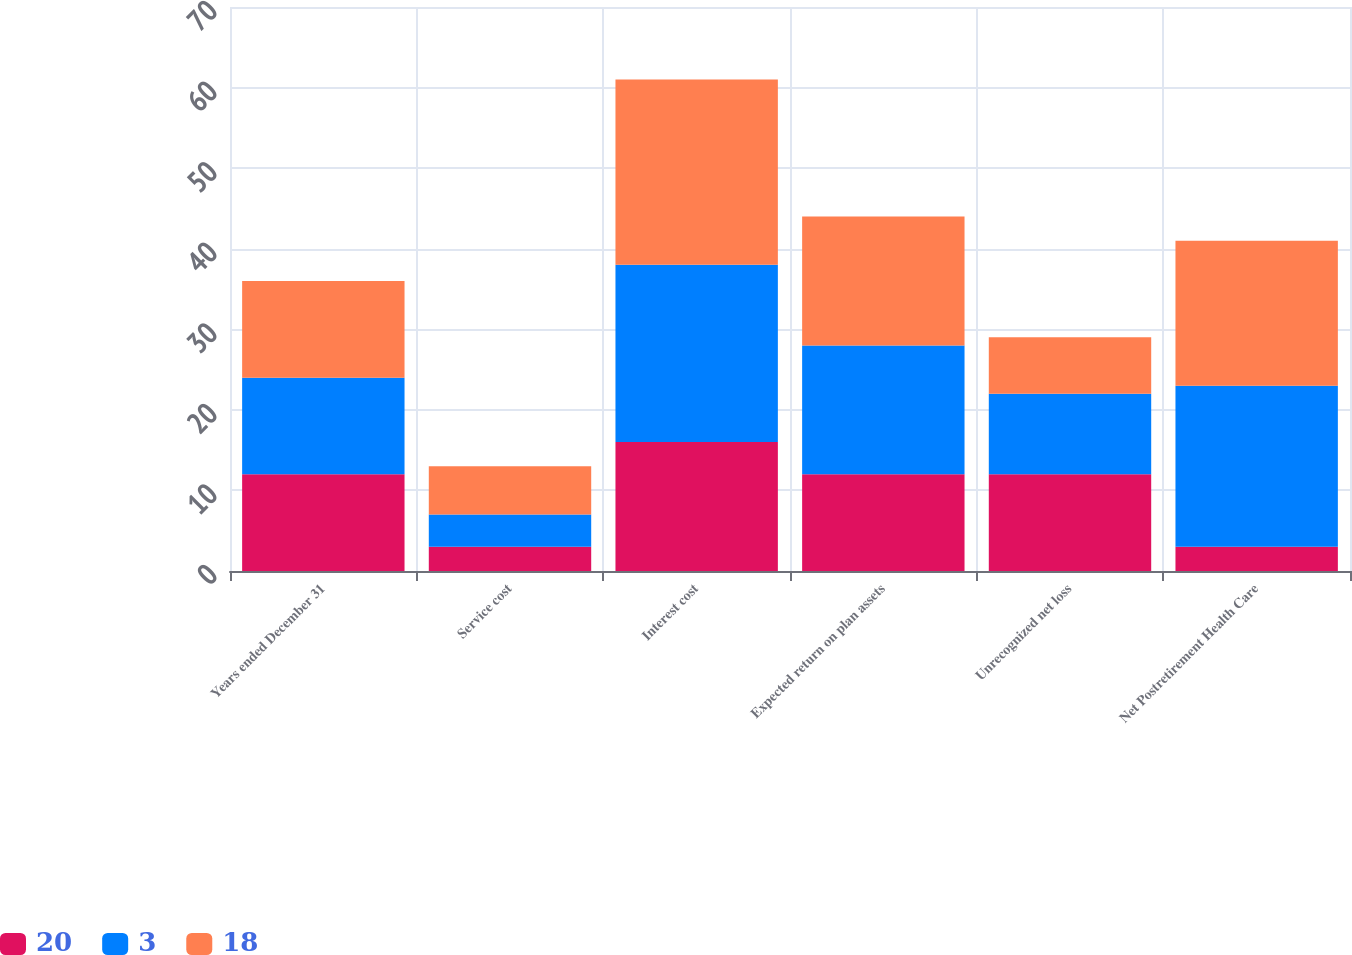Convert chart. <chart><loc_0><loc_0><loc_500><loc_500><stacked_bar_chart><ecel><fcel>Years ended December 31<fcel>Service cost<fcel>Interest cost<fcel>Expected return on plan assets<fcel>Unrecognized net loss<fcel>Net Postretirement Health Care<nl><fcel>20<fcel>12<fcel>3<fcel>16<fcel>12<fcel>12<fcel>3<nl><fcel>3<fcel>12<fcel>4<fcel>22<fcel>16<fcel>10<fcel>20<nl><fcel>18<fcel>12<fcel>6<fcel>23<fcel>16<fcel>7<fcel>18<nl></chart> 